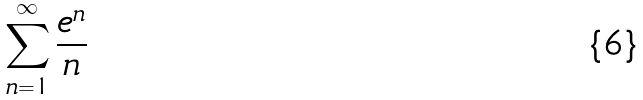<formula> <loc_0><loc_0><loc_500><loc_500>\sum _ { n = 1 } ^ { \infty } \frac { e ^ { n } } { n }</formula> 